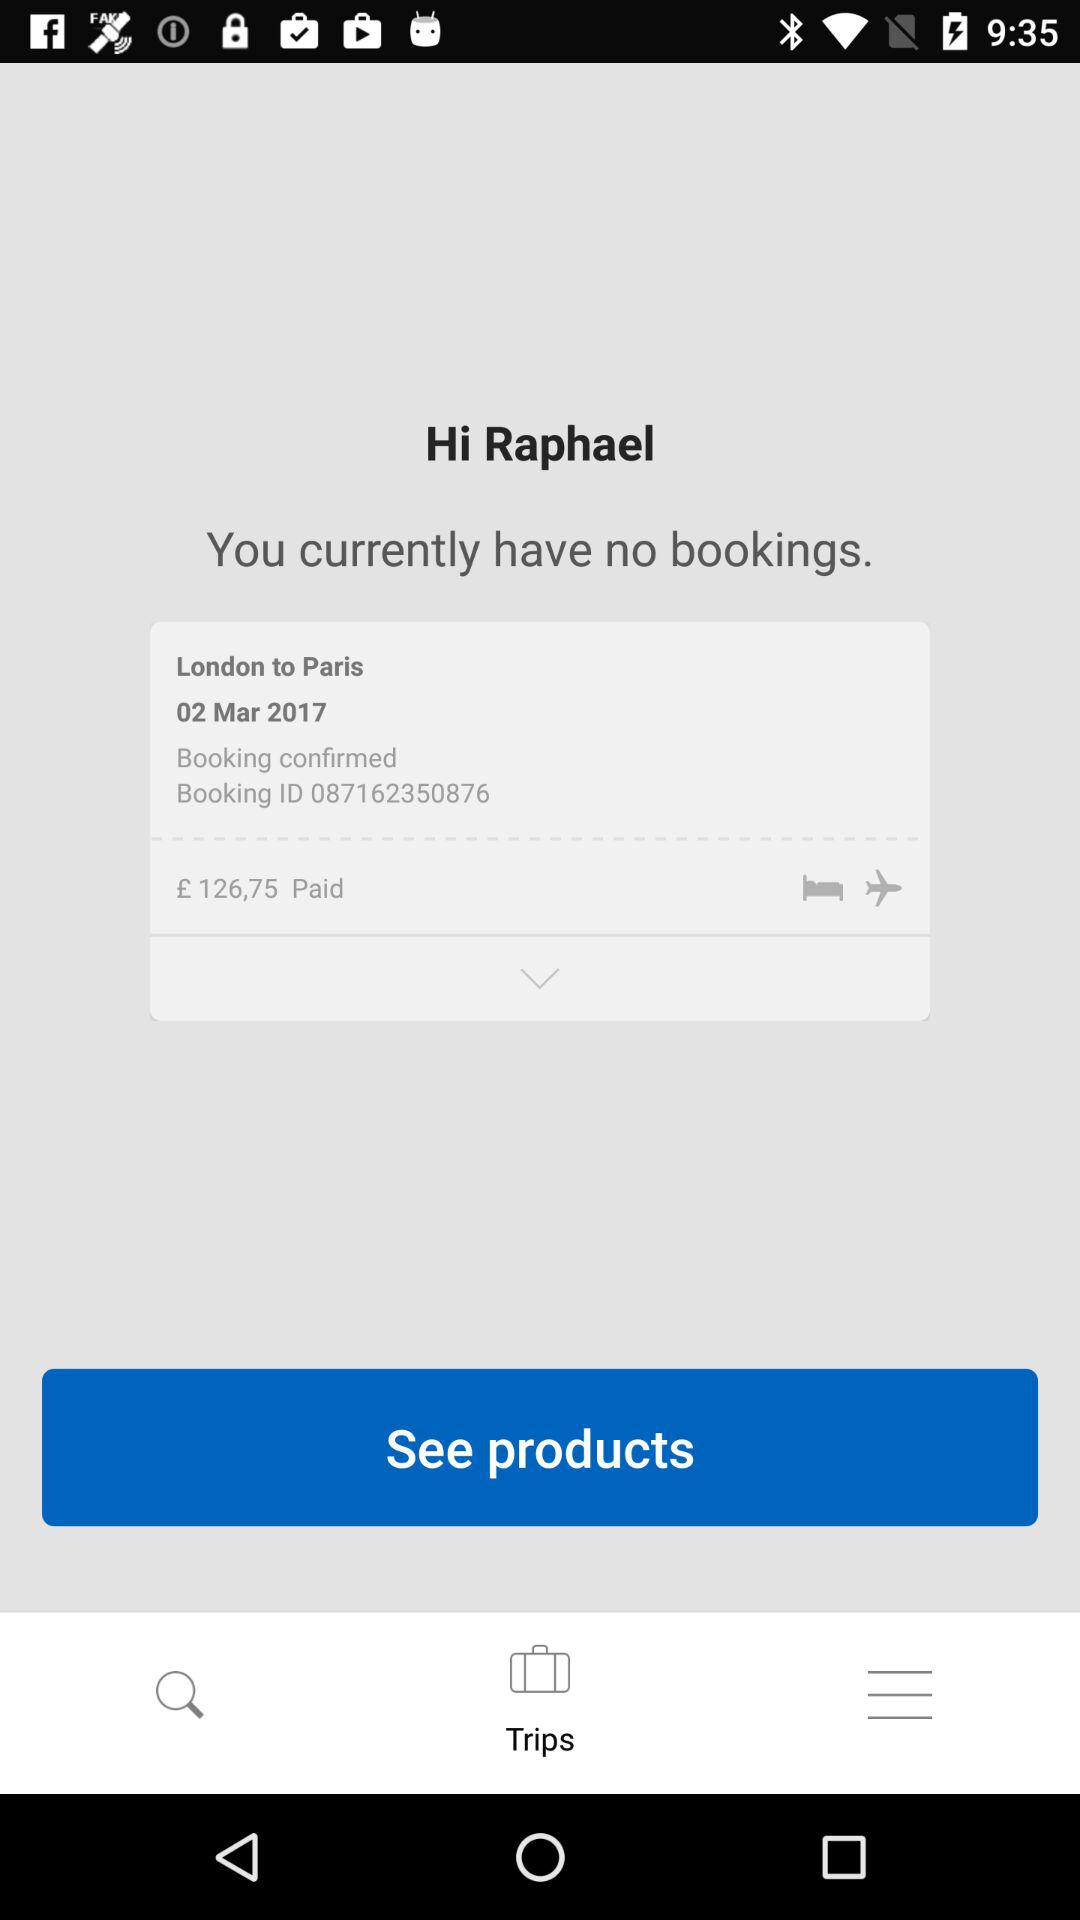What was the last booking ID? The last booking ID was 087162350876. 